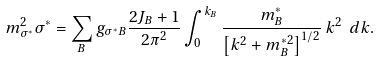<formula> <loc_0><loc_0><loc_500><loc_500>m _ { \sigma ^ { * } } ^ { 2 } \sigma ^ { * } = \sum _ { B } g _ { \sigma ^ { * } B } \frac { 2 J _ { B } + 1 } { 2 \pi ^ { 2 } } \int _ { 0 } ^ { k _ { B } } \frac { m _ { B } ^ { * } } { \left [ k ^ { 2 } + m _ { B } ^ { * 2 } \right ] ^ { 1 / 2 } } \, k ^ { 2 } \ d k .</formula> 